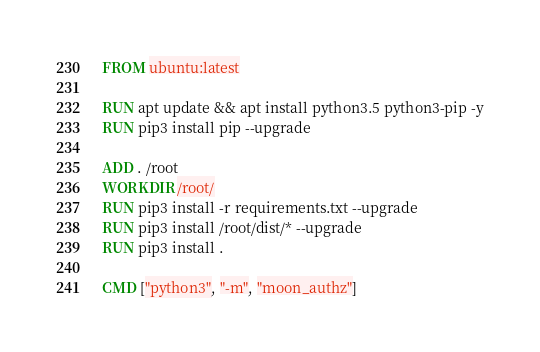Convert code to text. <code><loc_0><loc_0><loc_500><loc_500><_Dockerfile_>FROM ubuntu:latest

RUN apt update && apt install python3.5 python3-pip -y
RUN pip3 install pip --upgrade

ADD . /root
WORKDIR /root/
RUN pip3 install -r requirements.txt --upgrade
RUN pip3 install /root/dist/* --upgrade
RUN pip3 install .

CMD ["python3", "-m", "moon_authz"]</code> 